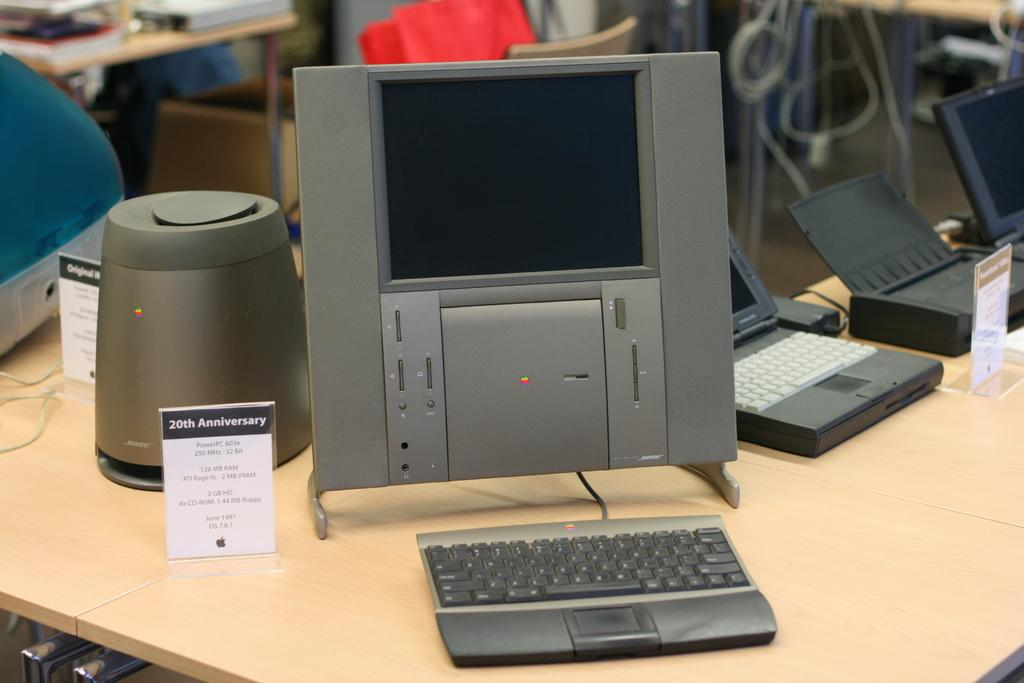<image>
Offer a succinct explanation of the picture presented. A laptop computer on a desk with a sign beside it reading 20th Anniversary. 